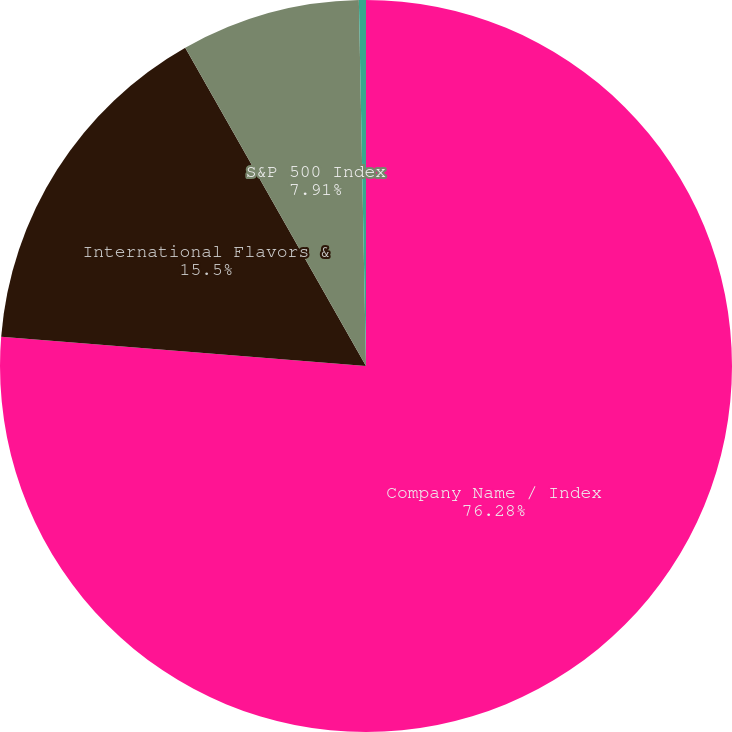<chart> <loc_0><loc_0><loc_500><loc_500><pie_chart><fcel>Company Name / Index<fcel>International Flavors &<fcel>S&P 500 Index<fcel>Peer Group<nl><fcel>76.27%<fcel>15.5%<fcel>7.91%<fcel>0.31%<nl></chart> 